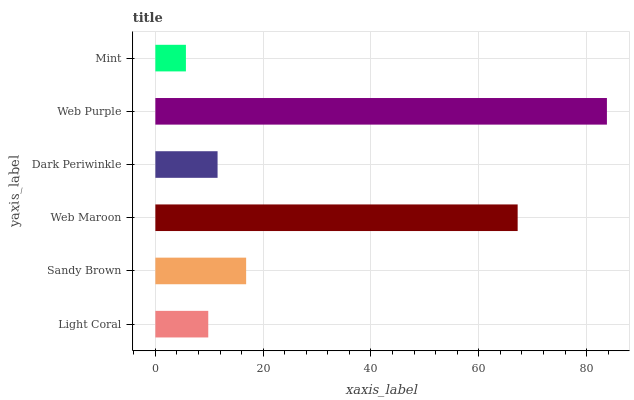Is Mint the minimum?
Answer yes or no. Yes. Is Web Purple the maximum?
Answer yes or no. Yes. Is Sandy Brown the minimum?
Answer yes or no. No. Is Sandy Brown the maximum?
Answer yes or no. No. Is Sandy Brown greater than Light Coral?
Answer yes or no. Yes. Is Light Coral less than Sandy Brown?
Answer yes or no. Yes. Is Light Coral greater than Sandy Brown?
Answer yes or no. No. Is Sandy Brown less than Light Coral?
Answer yes or no. No. Is Sandy Brown the high median?
Answer yes or no. Yes. Is Dark Periwinkle the low median?
Answer yes or no. Yes. Is Dark Periwinkle the high median?
Answer yes or no. No. Is Light Coral the low median?
Answer yes or no. No. 